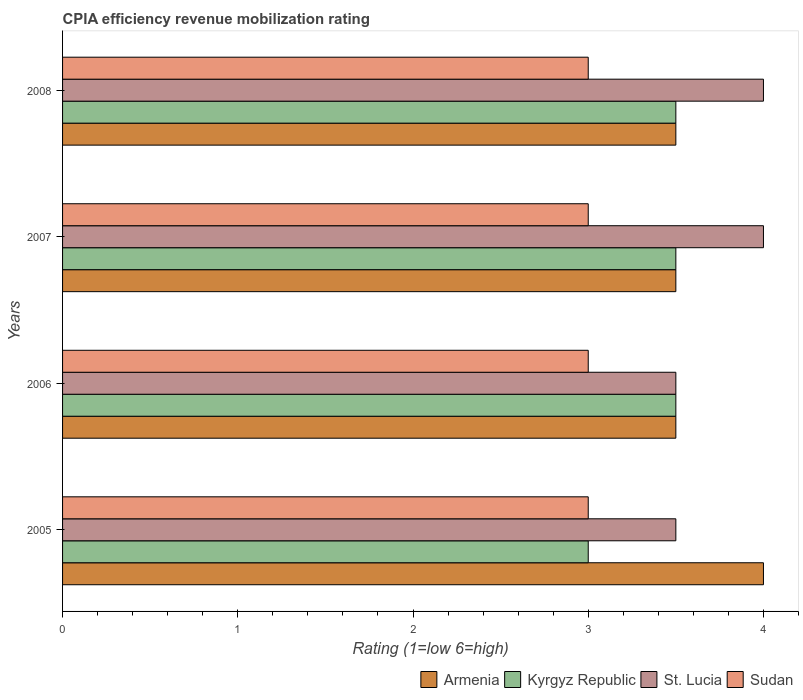Are the number of bars per tick equal to the number of legend labels?
Your answer should be very brief. Yes. Are the number of bars on each tick of the Y-axis equal?
Ensure brevity in your answer.  Yes. What is the label of the 4th group of bars from the top?
Provide a short and direct response. 2005. What is the CPIA rating in Armenia in 2006?
Give a very brief answer. 3.5. In which year was the CPIA rating in Kyrgyz Republic maximum?
Provide a short and direct response. 2006. What is the difference between the CPIA rating in Kyrgyz Republic in 2006 and that in 2007?
Your response must be concise. 0. What is the difference between the CPIA rating in Sudan in 2005 and the CPIA rating in Armenia in 2007?
Give a very brief answer. -0.5. What is the average CPIA rating in Kyrgyz Republic per year?
Your answer should be very brief. 3.38. In how many years, is the CPIA rating in St. Lucia greater than 2.6 ?
Ensure brevity in your answer.  4. What is the ratio of the CPIA rating in Kyrgyz Republic in 2005 to that in 2007?
Offer a terse response. 0.86. Is the CPIA rating in Sudan in 2006 less than that in 2007?
Make the answer very short. No. Is the difference between the CPIA rating in St. Lucia in 2007 and 2008 greater than the difference between the CPIA rating in Sudan in 2007 and 2008?
Ensure brevity in your answer.  No. In how many years, is the CPIA rating in St. Lucia greater than the average CPIA rating in St. Lucia taken over all years?
Your response must be concise. 2. Is the sum of the CPIA rating in Armenia in 2005 and 2007 greater than the maximum CPIA rating in Sudan across all years?
Give a very brief answer. Yes. What does the 2nd bar from the top in 2008 represents?
Offer a terse response. St. Lucia. What does the 3rd bar from the bottom in 2007 represents?
Offer a terse response. St. Lucia. Are the values on the major ticks of X-axis written in scientific E-notation?
Your answer should be compact. No. How are the legend labels stacked?
Give a very brief answer. Horizontal. What is the title of the graph?
Your answer should be very brief. CPIA efficiency revenue mobilization rating. Does "New Caledonia" appear as one of the legend labels in the graph?
Keep it short and to the point. No. What is the label or title of the X-axis?
Keep it short and to the point. Rating (1=low 6=high). What is the Rating (1=low 6=high) of Armenia in 2005?
Your answer should be very brief. 4. What is the Rating (1=low 6=high) in Kyrgyz Republic in 2005?
Make the answer very short. 3. What is the Rating (1=low 6=high) of St. Lucia in 2005?
Provide a succinct answer. 3.5. What is the Rating (1=low 6=high) in Sudan in 2005?
Your answer should be very brief. 3. What is the Rating (1=low 6=high) in Kyrgyz Republic in 2006?
Your response must be concise. 3.5. What is the Rating (1=low 6=high) of St. Lucia in 2006?
Keep it short and to the point. 3.5. What is the Rating (1=low 6=high) of Sudan in 2006?
Provide a short and direct response. 3. What is the Rating (1=low 6=high) of St. Lucia in 2007?
Give a very brief answer. 4. What is the Rating (1=low 6=high) of Sudan in 2007?
Give a very brief answer. 3. What is the Rating (1=low 6=high) of Armenia in 2008?
Offer a terse response. 3.5. What is the Rating (1=low 6=high) in St. Lucia in 2008?
Make the answer very short. 4. Across all years, what is the maximum Rating (1=low 6=high) of Kyrgyz Republic?
Your response must be concise. 3.5. Across all years, what is the minimum Rating (1=low 6=high) of Armenia?
Your response must be concise. 3.5. Across all years, what is the minimum Rating (1=low 6=high) of St. Lucia?
Give a very brief answer. 3.5. What is the total Rating (1=low 6=high) in St. Lucia in the graph?
Provide a short and direct response. 15. What is the difference between the Rating (1=low 6=high) of Kyrgyz Republic in 2005 and that in 2006?
Make the answer very short. -0.5. What is the difference between the Rating (1=low 6=high) in Sudan in 2005 and that in 2006?
Keep it short and to the point. 0. What is the difference between the Rating (1=low 6=high) in St. Lucia in 2005 and that in 2007?
Provide a short and direct response. -0.5. What is the difference between the Rating (1=low 6=high) in Sudan in 2005 and that in 2007?
Provide a succinct answer. 0. What is the difference between the Rating (1=low 6=high) in Sudan in 2005 and that in 2008?
Provide a succinct answer. 0. What is the difference between the Rating (1=low 6=high) in Sudan in 2006 and that in 2007?
Provide a succinct answer. 0. What is the difference between the Rating (1=low 6=high) of Kyrgyz Republic in 2006 and that in 2008?
Provide a short and direct response. 0. What is the difference between the Rating (1=low 6=high) of St. Lucia in 2006 and that in 2008?
Provide a short and direct response. -0.5. What is the difference between the Rating (1=low 6=high) in Armenia in 2007 and that in 2008?
Your response must be concise. 0. What is the difference between the Rating (1=low 6=high) in St. Lucia in 2007 and that in 2008?
Give a very brief answer. 0. What is the difference between the Rating (1=low 6=high) of Armenia in 2005 and the Rating (1=low 6=high) of Kyrgyz Republic in 2006?
Offer a terse response. 0.5. What is the difference between the Rating (1=low 6=high) of Armenia in 2005 and the Rating (1=low 6=high) of St. Lucia in 2006?
Ensure brevity in your answer.  0.5. What is the difference between the Rating (1=low 6=high) of Armenia in 2005 and the Rating (1=low 6=high) of Sudan in 2006?
Your answer should be compact. 1. What is the difference between the Rating (1=low 6=high) in Kyrgyz Republic in 2005 and the Rating (1=low 6=high) in Sudan in 2006?
Provide a short and direct response. 0. What is the difference between the Rating (1=low 6=high) in St. Lucia in 2005 and the Rating (1=low 6=high) in Sudan in 2006?
Keep it short and to the point. 0.5. What is the difference between the Rating (1=low 6=high) of Kyrgyz Republic in 2005 and the Rating (1=low 6=high) of St. Lucia in 2007?
Keep it short and to the point. -1. What is the difference between the Rating (1=low 6=high) of Kyrgyz Republic in 2005 and the Rating (1=low 6=high) of Sudan in 2007?
Offer a very short reply. 0. What is the difference between the Rating (1=low 6=high) of St. Lucia in 2005 and the Rating (1=low 6=high) of Sudan in 2007?
Ensure brevity in your answer.  0.5. What is the difference between the Rating (1=low 6=high) of Armenia in 2005 and the Rating (1=low 6=high) of Kyrgyz Republic in 2008?
Your response must be concise. 0.5. What is the difference between the Rating (1=low 6=high) in St. Lucia in 2005 and the Rating (1=low 6=high) in Sudan in 2008?
Ensure brevity in your answer.  0.5. What is the difference between the Rating (1=low 6=high) of Armenia in 2006 and the Rating (1=low 6=high) of Kyrgyz Republic in 2007?
Your answer should be compact. 0. What is the difference between the Rating (1=low 6=high) in Armenia in 2006 and the Rating (1=low 6=high) in Sudan in 2008?
Your response must be concise. 0.5. What is the difference between the Rating (1=low 6=high) in Kyrgyz Republic in 2006 and the Rating (1=low 6=high) in Sudan in 2008?
Give a very brief answer. 0.5. What is the difference between the Rating (1=low 6=high) of Armenia in 2007 and the Rating (1=low 6=high) of St. Lucia in 2008?
Give a very brief answer. -0.5. What is the average Rating (1=low 6=high) of Armenia per year?
Offer a terse response. 3.62. What is the average Rating (1=low 6=high) of Kyrgyz Republic per year?
Provide a succinct answer. 3.38. What is the average Rating (1=low 6=high) of St. Lucia per year?
Provide a short and direct response. 3.75. What is the average Rating (1=low 6=high) of Sudan per year?
Offer a terse response. 3. In the year 2005, what is the difference between the Rating (1=low 6=high) in Armenia and Rating (1=low 6=high) in St. Lucia?
Offer a very short reply. 0.5. In the year 2005, what is the difference between the Rating (1=low 6=high) in Armenia and Rating (1=low 6=high) in Sudan?
Your answer should be very brief. 1. In the year 2005, what is the difference between the Rating (1=low 6=high) of Kyrgyz Republic and Rating (1=low 6=high) of St. Lucia?
Make the answer very short. -0.5. In the year 2006, what is the difference between the Rating (1=low 6=high) in Armenia and Rating (1=low 6=high) in Sudan?
Offer a terse response. 0.5. In the year 2006, what is the difference between the Rating (1=low 6=high) of St. Lucia and Rating (1=low 6=high) of Sudan?
Your response must be concise. 0.5. In the year 2007, what is the difference between the Rating (1=low 6=high) of Armenia and Rating (1=low 6=high) of St. Lucia?
Offer a terse response. -0.5. In the year 2007, what is the difference between the Rating (1=low 6=high) of Kyrgyz Republic and Rating (1=low 6=high) of St. Lucia?
Your response must be concise. -0.5. In the year 2007, what is the difference between the Rating (1=low 6=high) of Kyrgyz Republic and Rating (1=low 6=high) of Sudan?
Your answer should be compact. 0.5. In the year 2007, what is the difference between the Rating (1=low 6=high) in St. Lucia and Rating (1=low 6=high) in Sudan?
Ensure brevity in your answer.  1. In the year 2008, what is the difference between the Rating (1=low 6=high) of Armenia and Rating (1=low 6=high) of Kyrgyz Republic?
Your answer should be very brief. 0. In the year 2008, what is the difference between the Rating (1=low 6=high) of Armenia and Rating (1=low 6=high) of Sudan?
Ensure brevity in your answer.  0.5. In the year 2008, what is the difference between the Rating (1=low 6=high) of Kyrgyz Republic and Rating (1=low 6=high) of St. Lucia?
Keep it short and to the point. -0.5. What is the ratio of the Rating (1=low 6=high) of Armenia in 2005 to that in 2006?
Provide a short and direct response. 1.14. What is the ratio of the Rating (1=low 6=high) of Kyrgyz Republic in 2005 to that in 2006?
Offer a very short reply. 0.86. What is the ratio of the Rating (1=low 6=high) in Sudan in 2005 to that in 2006?
Your answer should be compact. 1. What is the ratio of the Rating (1=low 6=high) in Armenia in 2005 to that in 2007?
Give a very brief answer. 1.14. What is the ratio of the Rating (1=low 6=high) in Kyrgyz Republic in 2005 to that in 2007?
Offer a very short reply. 0.86. What is the ratio of the Rating (1=low 6=high) in St. Lucia in 2005 to that in 2007?
Offer a terse response. 0.88. What is the ratio of the Rating (1=low 6=high) in Sudan in 2005 to that in 2007?
Offer a very short reply. 1. What is the ratio of the Rating (1=low 6=high) in St. Lucia in 2005 to that in 2008?
Provide a short and direct response. 0.88. What is the ratio of the Rating (1=low 6=high) in Kyrgyz Republic in 2006 to that in 2007?
Ensure brevity in your answer.  1. What is the ratio of the Rating (1=low 6=high) in Kyrgyz Republic in 2007 to that in 2008?
Your answer should be very brief. 1. What is the ratio of the Rating (1=low 6=high) of St. Lucia in 2007 to that in 2008?
Your response must be concise. 1. What is the ratio of the Rating (1=low 6=high) of Sudan in 2007 to that in 2008?
Your answer should be very brief. 1. What is the difference between the highest and the second highest Rating (1=low 6=high) of Armenia?
Offer a very short reply. 0.5. What is the difference between the highest and the second highest Rating (1=low 6=high) of Kyrgyz Republic?
Give a very brief answer. 0. What is the difference between the highest and the second highest Rating (1=low 6=high) in St. Lucia?
Ensure brevity in your answer.  0. What is the difference between the highest and the lowest Rating (1=low 6=high) of Armenia?
Your response must be concise. 0.5. What is the difference between the highest and the lowest Rating (1=low 6=high) in St. Lucia?
Your response must be concise. 0.5. What is the difference between the highest and the lowest Rating (1=low 6=high) in Sudan?
Give a very brief answer. 0. 